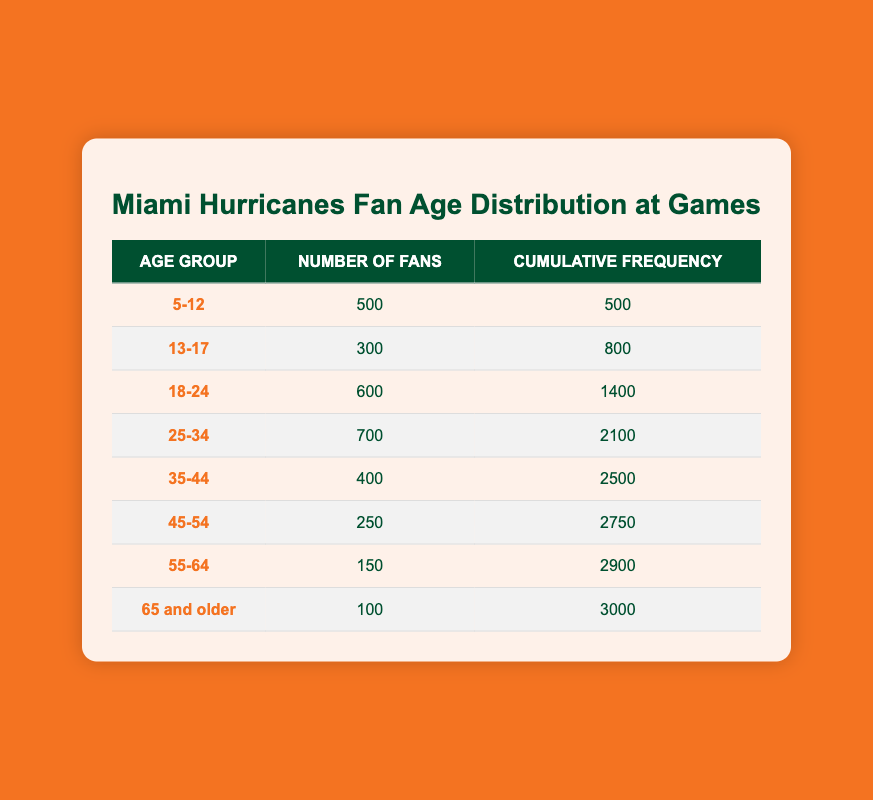What is the total number of fans aged 18 and younger? To find the total number of fans aged 18 and younger, we need to sum the number of fans in the age groups of 5-12 and 13-17. From the table, 500 fans are in the 5-12 age group and 300 fans are in the 13-17 age group. Adding these together gives us 500 + 300 = 800 fans.
Answer: 800 What percentage of fans are aged 25-34? To determine the percentage of fans aged 25-34, we first find the total number of fans, which is 3000. The number of fans in the 25-34 age group is 700. We calculate the percentage by dividing the number of fans in this age group by the total number of fans and then multiplying by 100: (700 / 3000) * 100 = 23.33%.
Answer: 23.33% Is the number of fans aged 65 and older greater than those aged 55-64? From the table, the number of fans aged 65 and older is 100, while the number of fans aged 55-64 is 150. Since 100 is less than 150, the statement is false.
Answer: No What is the cumulative frequency for fans aged 35-44? The cumulative frequency for fans aged 35-44 is directly listed in the table. It shows that there are 2500 fans when including all age groups up to 35-44. Therefore, the cumulative frequency for that age group is 2500.
Answer: 2500 Between the age groups of 25-34 and 35-44, which has more fans? The age group of 25-34 has 700 fans while the 35-44 age group has 400 fans. Since 700 is greater than 400, the 25-34 age group has more fans.
Answer: 25-34 What is the average number of fans across the age groups? To find the average number of fans, we sum the number of fans in all age groups: 500 + 300 + 600 + 700 + 400 + 250 + 150 + 100 = 3000. Then, we divide this total by the number of age groups, which is 8. The average is 3000 / 8 = 375.
Answer: 375 How many more fans are there in the 18-24 age group than in the 55-64 age group? The number of fans in the 18-24 age group is 600, and in the 55-64 age group, there are 150 fans. To find the difference, we subtract the number of fans in the 55-64 age group from those in the 18-24 age group: 600 - 150 = 450 more fans.
Answer: 450 What is the total number of fans in age groups over 50 years old? To calculate the total number of fans who are over 50 years old, we need to sum the fans in the age groups of 55-64 and 65 and older. From the table, there are 150 fans aged 55-64 and 100 fans aged 65 and older. The total is 150 + 100 = 250 fans over 50.
Answer: 250 Is the cumulative frequency for the 45-54 age group more than half of the total number of fans? The cumulative frequency for the 45-54 age group is listed as 2750. Half of the total number of fans (3000) is 1500. Since 2750 is greater than 1500, the statement is true.
Answer: Yes 